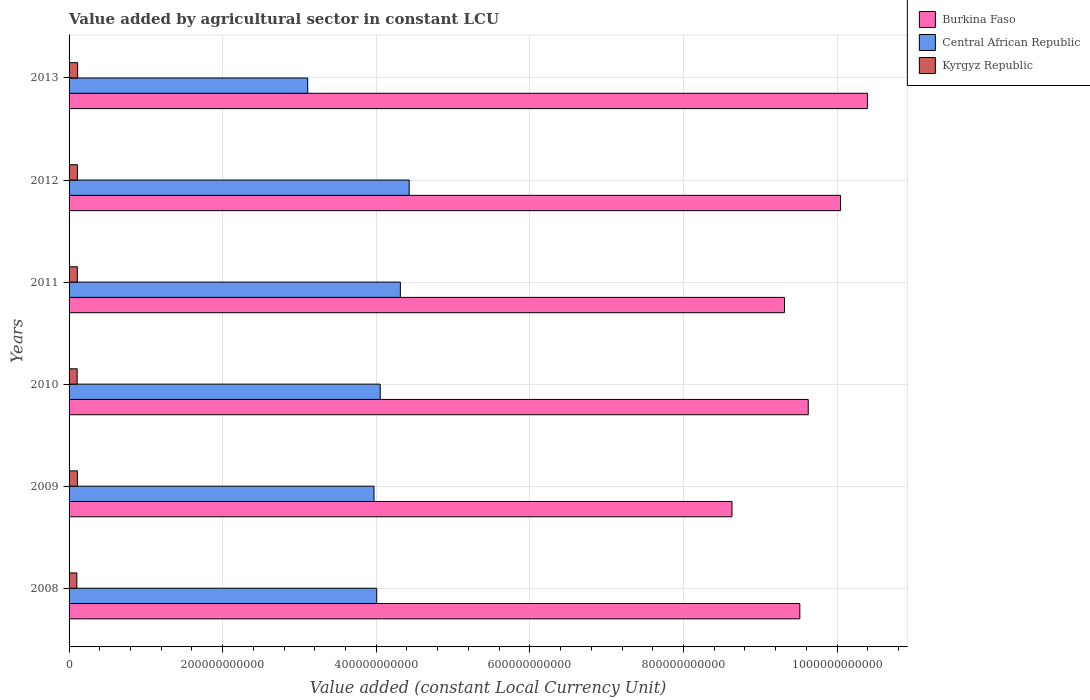How many groups of bars are there?
Ensure brevity in your answer.  6. Are the number of bars per tick equal to the number of legend labels?
Provide a succinct answer. Yes. How many bars are there on the 5th tick from the top?
Make the answer very short. 3. What is the label of the 4th group of bars from the top?
Offer a very short reply. 2010. In how many cases, is the number of bars for a given year not equal to the number of legend labels?
Provide a short and direct response. 0. What is the value added by agricultural sector in Burkina Faso in 2008?
Give a very brief answer. 9.52e+11. Across all years, what is the maximum value added by agricultural sector in Kyrgyz Republic?
Provide a short and direct response. 1.11e+1. Across all years, what is the minimum value added by agricultural sector in Burkina Faso?
Provide a succinct answer. 8.63e+11. What is the total value added by agricultural sector in Central African Republic in the graph?
Provide a short and direct response. 2.39e+12. What is the difference between the value added by agricultural sector in Kyrgyz Republic in 2012 and that in 2013?
Ensure brevity in your answer.  -2.85e+08. What is the difference between the value added by agricultural sector in Burkina Faso in 2011 and the value added by agricultural sector in Kyrgyz Republic in 2012?
Your answer should be compact. 9.21e+11. What is the average value added by agricultural sector in Central African Republic per year?
Give a very brief answer. 3.98e+11. In the year 2012, what is the difference between the value added by agricultural sector in Burkina Faso and value added by agricultural sector in Central African Republic?
Offer a very short reply. 5.62e+11. In how many years, is the value added by agricultural sector in Kyrgyz Republic greater than 960000000000 LCU?
Make the answer very short. 0. What is the ratio of the value added by agricultural sector in Burkina Faso in 2008 to that in 2011?
Provide a short and direct response. 1.02. Is the value added by agricultural sector in Kyrgyz Republic in 2008 less than that in 2010?
Your answer should be compact. Yes. Is the difference between the value added by agricultural sector in Burkina Faso in 2008 and 2013 greater than the difference between the value added by agricultural sector in Central African Republic in 2008 and 2013?
Keep it short and to the point. No. What is the difference between the highest and the second highest value added by agricultural sector in Kyrgyz Republic?
Your response must be concise. 2.85e+08. What is the difference between the highest and the lowest value added by agricultural sector in Burkina Faso?
Provide a succinct answer. 1.76e+11. Is the sum of the value added by agricultural sector in Central African Republic in 2009 and 2013 greater than the maximum value added by agricultural sector in Burkina Faso across all years?
Offer a terse response. No. What does the 2nd bar from the top in 2011 represents?
Offer a terse response. Central African Republic. What does the 3rd bar from the bottom in 2010 represents?
Your response must be concise. Kyrgyz Republic. Is it the case that in every year, the sum of the value added by agricultural sector in Central African Republic and value added by agricultural sector in Burkina Faso is greater than the value added by agricultural sector in Kyrgyz Republic?
Your answer should be compact. Yes. Are all the bars in the graph horizontal?
Keep it short and to the point. Yes. What is the difference between two consecutive major ticks on the X-axis?
Ensure brevity in your answer.  2.00e+11. Does the graph contain any zero values?
Your response must be concise. No. How many legend labels are there?
Make the answer very short. 3. What is the title of the graph?
Offer a terse response. Value added by agricultural sector in constant LCU. What is the label or title of the X-axis?
Offer a terse response. Value added (constant Local Currency Unit). What is the Value added (constant Local Currency Unit) of Burkina Faso in 2008?
Provide a succinct answer. 9.52e+11. What is the Value added (constant Local Currency Unit) in Central African Republic in 2008?
Your answer should be very brief. 4.01e+11. What is the Value added (constant Local Currency Unit) of Kyrgyz Republic in 2008?
Ensure brevity in your answer.  1.01e+1. What is the Value added (constant Local Currency Unit) of Burkina Faso in 2009?
Offer a terse response. 8.63e+11. What is the Value added (constant Local Currency Unit) in Central African Republic in 2009?
Offer a terse response. 3.97e+11. What is the Value added (constant Local Currency Unit) in Kyrgyz Republic in 2009?
Ensure brevity in your answer.  1.08e+1. What is the Value added (constant Local Currency Unit) of Burkina Faso in 2010?
Your response must be concise. 9.63e+11. What is the Value added (constant Local Currency Unit) of Central African Republic in 2010?
Ensure brevity in your answer.  4.05e+11. What is the Value added (constant Local Currency Unit) of Kyrgyz Republic in 2010?
Give a very brief answer. 1.05e+1. What is the Value added (constant Local Currency Unit) of Burkina Faso in 2011?
Your response must be concise. 9.32e+11. What is the Value added (constant Local Currency Unit) of Central African Republic in 2011?
Make the answer very short. 4.31e+11. What is the Value added (constant Local Currency Unit) of Kyrgyz Republic in 2011?
Provide a succinct answer. 1.07e+1. What is the Value added (constant Local Currency Unit) in Burkina Faso in 2012?
Make the answer very short. 1.00e+12. What is the Value added (constant Local Currency Unit) in Central African Republic in 2012?
Offer a very short reply. 4.43e+11. What is the Value added (constant Local Currency Unit) in Kyrgyz Republic in 2012?
Provide a short and direct response. 1.09e+1. What is the Value added (constant Local Currency Unit) in Burkina Faso in 2013?
Your answer should be very brief. 1.04e+12. What is the Value added (constant Local Currency Unit) of Central African Republic in 2013?
Your answer should be compact. 3.11e+11. What is the Value added (constant Local Currency Unit) of Kyrgyz Republic in 2013?
Provide a short and direct response. 1.11e+1. Across all years, what is the maximum Value added (constant Local Currency Unit) of Burkina Faso?
Your answer should be very brief. 1.04e+12. Across all years, what is the maximum Value added (constant Local Currency Unit) of Central African Republic?
Keep it short and to the point. 4.43e+11. Across all years, what is the maximum Value added (constant Local Currency Unit) of Kyrgyz Republic?
Make the answer very short. 1.11e+1. Across all years, what is the minimum Value added (constant Local Currency Unit) of Burkina Faso?
Your response must be concise. 8.63e+11. Across all years, what is the minimum Value added (constant Local Currency Unit) of Central African Republic?
Offer a terse response. 3.11e+11. Across all years, what is the minimum Value added (constant Local Currency Unit) in Kyrgyz Republic?
Keep it short and to the point. 1.01e+1. What is the total Value added (constant Local Currency Unit) in Burkina Faso in the graph?
Your answer should be very brief. 5.75e+12. What is the total Value added (constant Local Currency Unit) of Central African Republic in the graph?
Provide a short and direct response. 2.39e+12. What is the total Value added (constant Local Currency Unit) in Kyrgyz Republic in the graph?
Ensure brevity in your answer.  6.42e+1. What is the difference between the Value added (constant Local Currency Unit) of Burkina Faso in 2008 and that in 2009?
Make the answer very short. 8.84e+1. What is the difference between the Value added (constant Local Currency Unit) in Central African Republic in 2008 and that in 2009?
Make the answer very short. 3.55e+09. What is the difference between the Value added (constant Local Currency Unit) in Kyrgyz Republic in 2008 and that in 2009?
Provide a succinct answer. -6.81e+08. What is the difference between the Value added (constant Local Currency Unit) of Burkina Faso in 2008 and that in 2010?
Provide a succinct answer. -1.09e+1. What is the difference between the Value added (constant Local Currency Unit) in Central African Republic in 2008 and that in 2010?
Offer a very short reply. -4.55e+09. What is the difference between the Value added (constant Local Currency Unit) of Kyrgyz Republic in 2008 and that in 2010?
Make the answer very short. -4.03e+08. What is the difference between the Value added (constant Local Currency Unit) of Burkina Faso in 2008 and that in 2011?
Give a very brief answer. 2.00e+1. What is the difference between the Value added (constant Local Currency Unit) of Central African Republic in 2008 and that in 2011?
Your answer should be compact. -3.08e+1. What is the difference between the Value added (constant Local Currency Unit) in Kyrgyz Republic in 2008 and that in 2011?
Your response must be concise. -5.98e+08. What is the difference between the Value added (constant Local Currency Unit) in Burkina Faso in 2008 and that in 2012?
Your answer should be compact. -5.30e+1. What is the difference between the Value added (constant Local Currency Unit) in Central African Republic in 2008 and that in 2012?
Provide a succinct answer. -4.22e+1. What is the difference between the Value added (constant Local Currency Unit) of Kyrgyz Republic in 2008 and that in 2012?
Your answer should be compact. -7.31e+08. What is the difference between the Value added (constant Local Currency Unit) of Burkina Faso in 2008 and that in 2013?
Your answer should be compact. -8.80e+1. What is the difference between the Value added (constant Local Currency Unit) of Central African Republic in 2008 and that in 2013?
Your response must be concise. 8.98e+1. What is the difference between the Value added (constant Local Currency Unit) in Kyrgyz Republic in 2008 and that in 2013?
Provide a short and direct response. -1.02e+09. What is the difference between the Value added (constant Local Currency Unit) in Burkina Faso in 2009 and that in 2010?
Your response must be concise. -9.93e+1. What is the difference between the Value added (constant Local Currency Unit) in Central African Republic in 2009 and that in 2010?
Ensure brevity in your answer.  -8.10e+09. What is the difference between the Value added (constant Local Currency Unit) of Kyrgyz Republic in 2009 and that in 2010?
Provide a short and direct response. 2.78e+08. What is the difference between the Value added (constant Local Currency Unit) of Burkina Faso in 2009 and that in 2011?
Your response must be concise. -6.83e+1. What is the difference between the Value added (constant Local Currency Unit) in Central African Republic in 2009 and that in 2011?
Offer a terse response. -3.43e+1. What is the difference between the Value added (constant Local Currency Unit) in Kyrgyz Republic in 2009 and that in 2011?
Provide a short and direct response. 8.37e+07. What is the difference between the Value added (constant Local Currency Unit) in Burkina Faso in 2009 and that in 2012?
Provide a succinct answer. -1.41e+11. What is the difference between the Value added (constant Local Currency Unit) in Central African Republic in 2009 and that in 2012?
Offer a terse response. -4.58e+1. What is the difference between the Value added (constant Local Currency Unit) of Kyrgyz Republic in 2009 and that in 2012?
Keep it short and to the point. -4.99e+07. What is the difference between the Value added (constant Local Currency Unit) of Burkina Faso in 2009 and that in 2013?
Make the answer very short. -1.76e+11. What is the difference between the Value added (constant Local Currency Unit) in Central African Republic in 2009 and that in 2013?
Your answer should be compact. 8.63e+1. What is the difference between the Value added (constant Local Currency Unit) in Kyrgyz Republic in 2009 and that in 2013?
Offer a terse response. -3.35e+08. What is the difference between the Value added (constant Local Currency Unit) in Burkina Faso in 2010 and that in 2011?
Your answer should be compact. 3.10e+1. What is the difference between the Value added (constant Local Currency Unit) in Central African Republic in 2010 and that in 2011?
Your answer should be very brief. -2.62e+1. What is the difference between the Value added (constant Local Currency Unit) of Kyrgyz Republic in 2010 and that in 2011?
Give a very brief answer. -1.94e+08. What is the difference between the Value added (constant Local Currency Unit) in Burkina Faso in 2010 and that in 2012?
Provide a succinct answer. -4.21e+1. What is the difference between the Value added (constant Local Currency Unit) in Central African Republic in 2010 and that in 2012?
Provide a short and direct response. -3.77e+1. What is the difference between the Value added (constant Local Currency Unit) in Kyrgyz Republic in 2010 and that in 2012?
Your answer should be compact. -3.28e+08. What is the difference between the Value added (constant Local Currency Unit) in Burkina Faso in 2010 and that in 2013?
Make the answer very short. -7.71e+1. What is the difference between the Value added (constant Local Currency Unit) in Central African Republic in 2010 and that in 2013?
Provide a short and direct response. 9.44e+1. What is the difference between the Value added (constant Local Currency Unit) of Kyrgyz Republic in 2010 and that in 2013?
Provide a short and direct response. -6.13e+08. What is the difference between the Value added (constant Local Currency Unit) of Burkina Faso in 2011 and that in 2012?
Offer a terse response. -7.30e+1. What is the difference between the Value added (constant Local Currency Unit) in Central African Republic in 2011 and that in 2012?
Offer a very short reply. -1.15e+1. What is the difference between the Value added (constant Local Currency Unit) in Kyrgyz Republic in 2011 and that in 2012?
Your answer should be very brief. -1.34e+08. What is the difference between the Value added (constant Local Currency Unit) in Burkina Faso in 2011 and that in 2013?
Provide a succinct answer. -1.08e+11. What is the difference between the Value added (constant Local Currency Unit) in Central African Republic in 2011 and that in 2013?
Offer a terse response. 1.21e+11. What is the difference between the Value added (constant Local Currency Unit) in Kyrgyz Republic in 2011 and that in 2013?
Give a very brief answer. -4.19e+08. What is the difference between the Value added (constant Local Currency Unit) of Burkina Faso in 2012 and that in 2013?
Provide a short and direct response. -3.50e+1. What is the difference between the Value added (constant Local Currency Unit) of Central African Republic in 2012 and that in 2013?
Provide a succinct answer. 1.32e+11. What is the difference between the Value added (constant Local Currency Unit) in Kyrgyz Republic in 2012 and that in 2013?
Ensure brevity in your answer.  -2.85e+08. What is the difference between the Value added (constant Local Currency Unit) of Burkina Faso in 2008 and the Value added (constant Local Currency Unit) of Central African Republic in 2009?
Make the answer very short. 5.54e+11. What is the difference between the Value added (constant Local Currency Unit) in Burkina Faso in 2008 and the Value added (constant Local Currency Unit) in Kyrgyz Republic in 2009?
Give a very brief answer. 9.41e+11. What is the difference between the Value added (constant Local Currency Unit) in Central African Republic in 2008 and the Value added (constant Local Currency Unit) in Kyrgyz Republic in 2009?
Provide a short and direct response. 3.90e+11. What is the difference between the Value added (constant Local Currency Unit) in Burkina Faso in 2008 and the Value added (constant Local Currency Unit) in Central African Republic in 2010?
Ensure brevity in your answer.  5.46e+11. What is the difference between the Value added (constant Local Currency Unit) of Burkina Faso in 2008 and the Value added (constant Local Currency Unit) of Kyrgyz Republic in 2010?
Provide a short and direct response. 9.41e+11. What is the difference between the Value added (constant Local Currency Unit) in Central African Republic in 2008 and the Value added (constant Local Currency Unit) in Kyrgyz Republic in 2010?
Ensure brevity in your answer.  3.90e+11. What is the difference between the Value added (constant Local Currency Unit) of Burkina Faso in 2008 and the Value added (constant Local Currency Unit) of Central African Republic in 2011?
Offer a terse response. 5.20e+11. What is the difference between the Value added (constant Local Currency Unit) of Burkina Faso in 2008 and the Value added (constant Local Currency Unit) of Kyrgyz Republic in 2011?
Offer a terse response. 9.41e+11. What is the difference between the Value added (constant Local Currency Unit) of Central African Republic in 2008 and the Value added (constant Local Currency Unit) of Kyrgyz Republic in 2011?
Provide a short and direct response. 3.90e+11. What is the difference between the Value added (constant Local Currency Unit) of Burkina Faso in 2008 and the Value added (constant Local Currency Unit) of Central African Republic in 2012?
Offer a very short reply. 5.09e+11. What is the difference between the Value added (constant Local Currency Unit) of Burkina Faso in 2008 and the Value added (constant Local Currency Unit) of Kyrgyz Republic in 2012?
Ensure brevity in your answer.  9.41e+11. What is the difference between the Value added (constant Local Currency Unit) in Central African Republic in 2008 and the Value added (constant Local Currency Unit) in Kyrgyz Republic in 2012?
Your answer should be very brief. 3.90e+11. What is the difference between the Value added (constant Local Currency Unit) in Burkina Faso in 2008 and the Value added (constant Local Currency Unit) in Central African Republic in 2013?
Give a very brief answer. 6.41e+11. What is the difference between the Value added (constant Local Currency Unit) of Burkina Faso in 2008 and the Value added (constant Local Currency Unit) of Kyrgyz Republic in 2013?
Your response must be concise. 9.40e+11. What is the difference between the Value added (constant Local Currency Unit) of Central African Republic in 2008 and the Value added (constant Local Currency Unit) of Kyrgyz Republic in 2013?
Keep it short and to the point. 3.89e+11. What is the difference between the Value added (constant Local Currency Unit) in Burkina Faso in 2009 and the Value added (constant Local Currency Unit) in Central African Republic in 2010?
Make the answer very short. 4.58e+11. What is the difference between the Value added (constant Local Currency Unit) in Burkina Faso in 2009 and the Value added (constant Local Currency Unit) in Kyrgyz Republic in 2010?
Offer a terse response. 8.53e+11. What is the difference between the Value added (constant Local Currency Unit) in Central African Republic in 2009 and the Value added (constant Local Currency Unit) in Kyrgyz Republic in 2010?
Keep it short and to the point. 3.87e+11. What is the difference between the Value added (constant Local Currency Unit) of Burkina Faso in 2009 and the Value added (constant Local Currency Unit) of Central African Republic in 2011?
Give a very brief answer. 4.32e+11. What is the difference between the Value added (constant Local Currency Unit) of Burkina Faso in 2009 and the Value added (constant Local Currency Unit) of Kyrgyz Republic in 2011?
Your response must be concise. 8.52e+11. What is the difference between the Value added (constant Local Currency Unit) in Central African Republic in 2009 and the Value added (constant Local Currency Unit) in Kyrgyz Republic in 2011?
Keep it short and to the point. 3.86e+11. What is the difference between the Value added (constant Local Currency Unit) of Burkina Faso in 2009 and the Value added (constant Local Currency Unit) of Central African Republic in 2012?
Provide a succinct answer. 4.20e+11. What is the difference between the Value added (constant Local Currency Unit) in Burkina Faso in 2009 and the Value added (constant Local Currency Unit) in Kyrgyz Republic in 2012?
Offer a terse response. 8.52e+11. What is the difference between the Value added (constant Local Currency Unit) of Central African Republic in 2009 and the Value added (constant Local Currency Unit) of Kyrgyz Republic in 2012?
Offer a terse response. 3.86e+11. What is the difference between the Value added (constant Local Currency Unit) of Burkina Faso in 2009 and the Value added (constant Local Currency Unit) of Central African Republic in 2013?
Make the answer very short. 5.52e+11. What is the difference between the Value added (constant Local Currency Unit) of Burkina Faso in 2009 and the Value added (constant Local Currency Unit) of Kyrgyz Republic in 2013?
Your response must be concise. 8.52e+11. What is the difference between the Value added (constant Local Currency Unit) of Central African Republic in 2009 and the Value added (constant Local Currency Unit) of Kyrgyz Republic in 2013?
Provide a short and direct response. 3.86e+11. What is the difference between the Value added (constant Local Currency Unit) of Burkina Faso in 2010 and the Value added (constant Local Currency Unit) of Central African Republic in 2011?
Offer a terse response. 5.31e+11. What is the difference between the Value added (constant Local Currency Unit) of Burkina Faso in 2010 and the Value added (constant Local Currency Unit) of Kyrgyz Republic in 2011?
Offer a terse response. 9.52e+11. What is the difference between the Value added (constant Local Currency Unit) of Central African Republic in 2010 and the Value added (constant Local Currency Unit) of Kyrgyz Republic in 2011?
Provide a short and direct response. 3.94e+11. What is the difference between the Value added (constant Local Currency Unit) of Burkina Faso in 2010 and the Value added (constant Local Currency Unit) of Central African Republic in 2012?
Provide a short and direct response. 5.20e+11. What is the difference between the Value added (constant Local Currency Unit) of Burkina Faso in 2010 and the Value added (constant Local Currency Unit) of Kyrgyz Republic in 2012?
Provide a short and direct response. 9.52e+11. What is the difference between the Value added (constant Local Currency Unit) in Central African Republic in 2010 and the Value added (constant Local Currency Unit) in Kyrgyz Republic in 2012?
Keep it short and to the point. 3.94e+11. What is the difference between the Value added (constant Local Currency Unit) in Burkina Faso in 2010 and the Value added (constant Local Currency Unit) in Central African Republic in 2013?
Your response must be concise. 6.52e+11. What is the difference between the Value added (constant Local Currency Unit) of Burkina Faso in 2010 and the Value added (constant Local Currency Unit) of Kyrgyz Republic in 2013?
Provide a succinct answer. 9.51e+11. What is the difference between the Value added (constant Local Currency Unit) in Central African Republic in 2010 and the Value added (constant Local Currency Unit) in Kyrgyz Republic in 2013?
Ensure brevity in your answer.  3.94e+11. What is the difference between the Value added (constant Local Currency Unit) in Burkina Faso in 2011 and the Value added (constant Local Currency Unit) in Central African Republic in 2012?
Provide a short and direct response. 4.89e+11. What is the difference between the Value added (constant Local Currency Unit) in Burkina Faso in 2011 and the Value added (constant Local Currency Unit) in Kyrgyz Republic in 2012?
Your answer should be compact. 9.21e+11. What is the difference between the Value added (constant Local Currency Unit) of Central African Republic in 2011 and the Value added (constant Local Currency Unit) of Kyrgyz Republic in 2012?
Provide a short and direct response. 4.21e+11. What is the difference between the Value added (constant Local Currency Unit) of Burkina Faso in 2011 and the Value added (constant Local Currency Unit) of Central African Republic in 2013?
Ensure brevity in your answer.  6.21e+11. What is the difference between the Value added (constant Local Currency Unit) of Burkina Faso in 2011 and the Value added (constant Local Currency Unit) of Kyrgyz Republic in 2013?
Your response must be concise. 9.20e+11. What is the difference between the Value added (constant Local Currency Unit) of Central African Republic in 2011 and the Value added (constant Local Currency Unit) of Kyrgyz Republic in 2013?
Offer a terse response. 4.20e+11. What is the difference between the Value added (constant Local Currency Unit) in Burkina Faso in 2012 and the Value added (constant Local Currency Unit) in Central African Republic in 2013?
Provide a succinct answer. 6.94e+11. What is the difference between the Value added (constant Local Currency Unit) of Burkina Faso in 2012 and the Value added (constant Local Currency Unit) of Kyrgyz Republic in 2013?
Offer a terse response. 9.93e+11. What is the difference between the Value added (constant Local Currency Unit) in Central African Republic in 2012 and the Value added (constant Local Currency Unit) in Kyrgyz Republic in 2013?
Give a very brief answer. 4.32e+11. What is the average Value added (constant Local Currency Unit) in Burkina Faso per year?
Make the answer very short. 9.59e+11. What is the average Value added (constant Local Currency Unit) of Central African Republic per year?
Offer a very short reply. 3.98e+11. What is the average Value added (constant Local Currency Unit) of Kyrgyz Republic per year?
Ensure brevity in your answer.  1.07e+1. In the year 2008, what is the difference between the Value added (constant Local Currency Unit) in Burkina Faso and Value added (constant Local Currency Unit) in Central African Republic?
Ensure brevity in your answer.  5.51e+11. In the year 2008, what is the difference between the Value added (constant Local Currency Unit) in Burkina Faso and Value added (constant Local Currency Unit) in Kyrgyz Republic?
Provide a short and direct response. 9.41e+11. In the year 2008, what is the difference between the Value added (constant Local Currency Unit) in Central African Republic and Value added (constant Local Currency Unit) in Kyrgyz Republic?
Offer a terse response. 3.90e+11. In the year 2009, what is the difference between the Value added (constant Local Currency Unit) in Burkina Faso and Value added (constant Local Currency Unit) in Central African Republic?
Keep it short and to the point. 4.66e+11. In the year 2009, what is the difference between the Value added (constant Local Currency Unit) of Burkina Faso and Value added (constant Local Currency Unit) of Kyrgyz Republic?
Provide a short and direct response. 8.52e+11. In the year 2009, what is the difference between the Value added (constant Local Currency Unit) of Central African Republic and Value added (constant Local Currency Unit) of Kyrgyz Republic?
Your response must be concise. 3.86e+11. In the year 2010, what is the difference between the Value added (constant Local Currency Unit) of Burkina Faso and Value added (constant Local Currency Unit) of Central African Republic?
Your answer should be very brief. 5.57e+11. In the year 2010, what is the difference between the Value added (constant Local Currency Unit) of Burkina Faso and Value added (constant Local Currency Unit) of Kyrgyz Republic?
Make the answer very short. 9.52e+11. In the year 2010, what is the difference between the Value added (constant Local Currency Unit) of Central African Republic and Value added (constant Local Currency Unit) of Kyrgyz Republic?
Give a very brief answer. 3.95e+11. In the year 2011, what is the difference between the Value added (constant Local Currency Unit) of Burkina Faso and Value added (constant Local Currency Unit) of Central African Republic?
Provide a short and direct response. 5.00e+11. In the year 2011, what is the difference between the Value added (constant Local Currency Unit) of Burkina Faso and Value added (constant Local Currency Unit) of Kyrgyz Republic?
Your answer should be compact. 9.21e+11. In the year 2011, what is the difference between the Value added (constant Local Currency Unit) of Central African Republic and Value added (constant Local Currency Unit) of Kyrgyz Republic?
Provide a short and direct response. 4.21e+11. In the year 2012, what is the difference between the Value added (constant Local Currency Unit) in Burkina Faso and Value added (constant Local Currency Unit) in Central African Republic?
Make the answer very short. 5.62e+11. In the year 2012, what is the difference between the Value added (constant Local Currency Unit) of Burkina Faso and Value added (constant Local Currency Unit) of Kyrgyz Republic?
Offer a terse response. 9.94e+11. In the year 2012, what is the difference between the Value added (constant Local Currency Unit) of Central African Republic and Value added (constant Local Currency Unit) of Kyrgyz Republic?
Make the answer very short. 4.32e+11. In the year 2013, what is the difference between the Value added (constant Local Currency Unit) in Burkina Faso and Value added (constant Local Currency Unit) in Central African Republic?
Give a very brief answer. 7.29e+11. In the year 2013, what is the difference between the Value added (constant Local Currency Unit) in Burkina Faso and Value added (constant Local Currency Unit) in Kyrgyz Republic?
Your answer should be very brief. 1.03e+12. In the year 2013, what is the difference between the Value added (constant Local Currency Unit) in Central African Republic and Value added (constant Local Currency Unit) in Kyrgyz Republic?
Your response must be concise. 3.00e+11. What is the ratio of the Value added (constant Local Currency Unit) in Burkina Faso in 2008 to that in 2009?
Provide a succinct answer. 1.1. What is the ratio of the Value added (constant Local Currency Unit) of Central African Republic in 2008 to that in 2009?
Provide a short and direct response. 1.01. What is the ratio of the Value added (constant Local Currency Unit) of Kyrgyz Republic in 2008 to that in 2009?
Your answer should be compact. 0.94. What is the ratio of the Value added (constant Local Currency Unit) in Kyrgyz Republic in 2008 to that in 2010?
Keep it short and to the point. 0.96. What is the ratio of the Value added (constant Local Currency Unit) of Burkina Faso in 2008 to that in 2011?
Your answer should be compact. 1.02. What is the ratio of the Value added (constant Local Currency Unit) in Kyrgyz Republic in 2008 to that in 2011?
Provide a succinct answer. 0.94. What is the ratio of the Value added (constant Local Currency Unit) in Burkina Faso in 2008 to that in 2012?
Offer a very short reply. 0.95. What is the ratio of the Value added (constant Local Currency Unit) of Central African Republic in 2008 to that in 2012?
Keep it short and to the point. 0.9. What is the ratio of the Value added (constant Local Currency Unit) of Kyrgyz Republic in 2008 to that in 2012?
Make the answer very short. 0.93. What is the ratio of the Value added (constant Local Currency Unit) of Burkina Faso in 2008 to that in 2013?
Provide a short and direct response. 0.92. What is the ratio of the Value added (constant Local Currency Unit) of Central African Republic in 2008 to that in 2013?
Your answer should be very brief. 1.29. What is the ratio of the Value added (constant Local Currency Unit) of Kyrgyz Republic in 2008 to that in 2013?
Provide a short and direct response. 0.91. What is the ratio of the Value added (constant Local Currency Unit) in Burkina Faso in 2009 to that in 2010?
Give a very brief answer. 0.9. What is the ratio of the Value added (constant Local Currency Unit) in Kyrgyz Republic in 2009 to that in 2010?
Your answer should be compact. 1.03. What is the ratio of the Value added (constant Local Currency Unit) in Burkina Faso in 2009 to that in 2011?
Provide a short and direct response. 0.93. What is the ratio of the Value added (constant Local Currency Unit) of Central African Republic in 2009 to that in 2011?
Your answer should be very brief. 0.92. What is the ratio of the Value added (constant Local Currency Unit) of Kyrgyz Republic in 2009 to that in 2011?
Ensure brevity in your answer.  1.01. What is the ratio of the Value added (constant Local Currency Unit) of Burkina Faso in 2009 to that in 2012?
Provide a succinct answer. 0.86. What is the ratio of the Value added (constant Local Currency Unit) in Central African Republic in 2009 to that in 2012?
Make the answer very short. 0.9. What is the ratio of the Value added (constant Local Currency Unit) of Kyrgyz Republic in 2009 to that in 2012?
Give a very brief answer. 1. What is the ratio of the Value added (constant Local Currency Unit) of Burkina Faso in 2009 to that in 2013?
Offer a terse response. 0.83. What is the ratio of the Value added (constant Local Currency Unit) in Central African Republic in 2009 to that in 2013?
Keep it short and to the point. 1.28. What is the ratio of the Value added (constant Local Currency Unit) in Kyrgyz Republic in 2009 to that in 2013?
Your response must be concise. 0.97. What is the ratio of the Value added (constant Local Currency Unit) of Burkina Faso in 2010 to that in 2011?
Provide a short and direct response. 1.03. What is the ratio of the Value added (constant Local Currency Unit) in Central African Republic in 2010 to that in 2011?
Your answer should be very brief. 0.94. What is the ratio of the Value added (constant Local Currency Unit) in Kyrgyz Republic in 2010 to that in 2011?
Make the answer very short. 0.98. What is the ratio of the Value added (constant Local Currency Unit) in Burkina Faso in 2010 to that in 2012?
Provide a succinct answer. 0.96. What is the ratio of the Value added (constant Local Currency Unit) in Central African Republic in 2010 to that in 2012?
Provide a short and direct response. 0.91. What is the ratio of the Value added (constant Local Currency Unit) in Kyrgyz Republic in 2010 to that in 2012?
Offer a very short reply. 0.97. What is the ratio of the Value added (constant Local Currency Unit) in Burkina Faso in 2010 to that in 2013?
Make the answer very short. 0.93. What is the ratio of the Value added (constant Local Currency Unit) in Central African Republic in 2010 to that in 2013?
Make the answer very short. 1.3. What is the ratio of the Value added (constant Local Currency Unit) of Kyrgyz Republic in 2010 to that in 2013?
Ensure brevity in your answer.  0.94. What is the ratio of the Value added (constant Local Currency Unit) in Burkina Faso in 2011 to that in 2012?
Offer a very short reply. 0.93. What is the ratio of the Value added (constant Local Currency Unit) in Central African Republic in 2011 to that in 2012?
Offer a very short reply. 0.97. What is the ratio of the Value added (constant Local Currency Unit) of Kyrgyz Republic in 2011 to that in 2012?
Make the answer very short. 0.99. What is the ratio of the Value added (constant Local Currency Unit) in Burkina Faso in 2011 to that in 2013?
Provide a short and direct response. 0.9. What is the ratio of the Value added (constant Local Currency Unit) of Central African Republic in 2011 to that in 2013?
Your response must be concise. 1.39. What is the ratio of the Value added (constant Local Currency Unit) of Kyrgyz Republic in 2011 to that in 2013?
Provide a short and direct response. 0.96. What is the ratio of the Value added (constant Local Currency Unit) of Burkina Faso in 2012 to that in 2013?
Make the answer very short. 0.97. What is the ratio of the Value added (constant Local Currency Unit) in Central African Republic in 2012 to that in 2013?
Offer a very short reply. 1.43. What is the ratio of the Value added (constant Local Currency Unit) of Kyrgyz Republic in 2012 to that in 2013?
Ensure brevity in your answer.  0.97. What is the difference between the highest and the second highest Value added (constant Local Currency Unit) of Burkina Faso?
Offer a terse response. 3.50e+1. What is the difference between the highest and the second highest Value added (constant Local Currency Unit) in Central African Republic?
Provide a succinct answer. 1.15e+1. What is the difference between the highest and the second highest Value added (constant Local Currency Unit) of Kyrgyz Republic?
Make the answer very short. 2.85e+08. What is the difference between the highest and the lowest Value added (constant Local Currency Unit) in Burkina Faso?
Offer a terse response. 1.76e+11. What is the difference between the highest and the lowest Value added (constant Local Currency Unit) in Central African Republic?
Provide a short and direct response. 1.32e+11. What is the difference between the highest and the lowest Value added (constant Local Currency Unit) in Kyrgyz Republic?
Your answer should be very brief. 1.02e+09. 